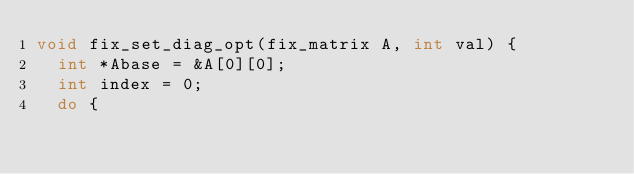Convert code to text. <code><loc_0><loc_0><loc_500><loc_500><_C_>void fix_set_diag_opt(fix_matrix A, int val) {
	int *Abase = &A[0][0];
	int index = 0;
	do {</code> 